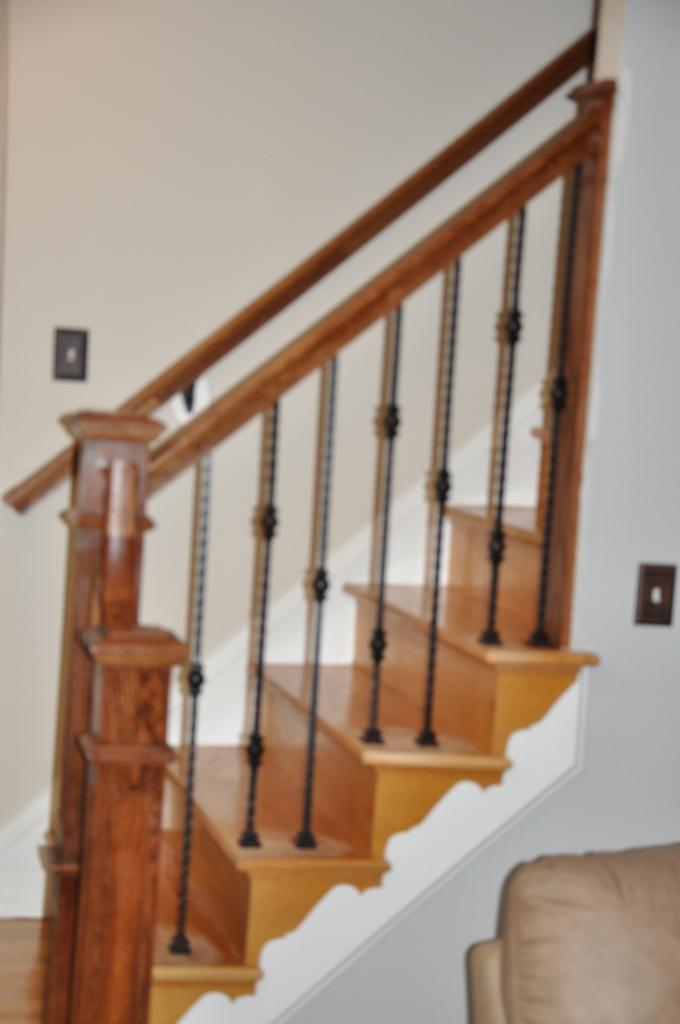Can you describe this image briefly? It is a staircase which is in brown color and this is the wall. 